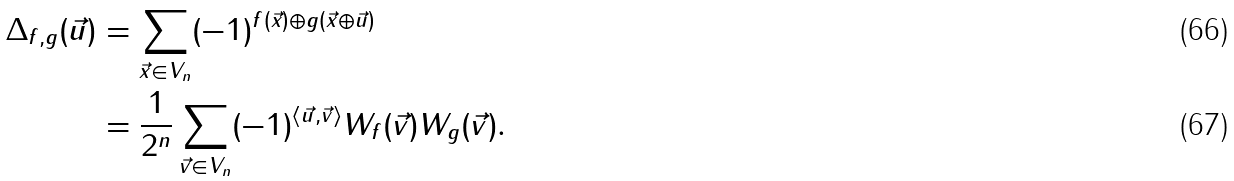Convert formula to latex. <formula><loc_0><loc_0><loc_500><loc_500>\Delta _ { f , g } ( \vec { u } ) & = \sum _ { \vec { x } \in V _ { n } } ( - 1 ) ^ { f ( \vec { x } ) \oplus g ( \vec { x } \oplus \vec { u } ) } \\ & = \frac { 1 } { 2 ^ { n } } \sum _ { \vec { v } \in V _ { n } } ( - 1 ) ^ { \langle \vec { u } , \vec { v } \rangle } W _ { f } ( \vec { v } ) W _ { g } ( \vec { v } ) .</formula> 